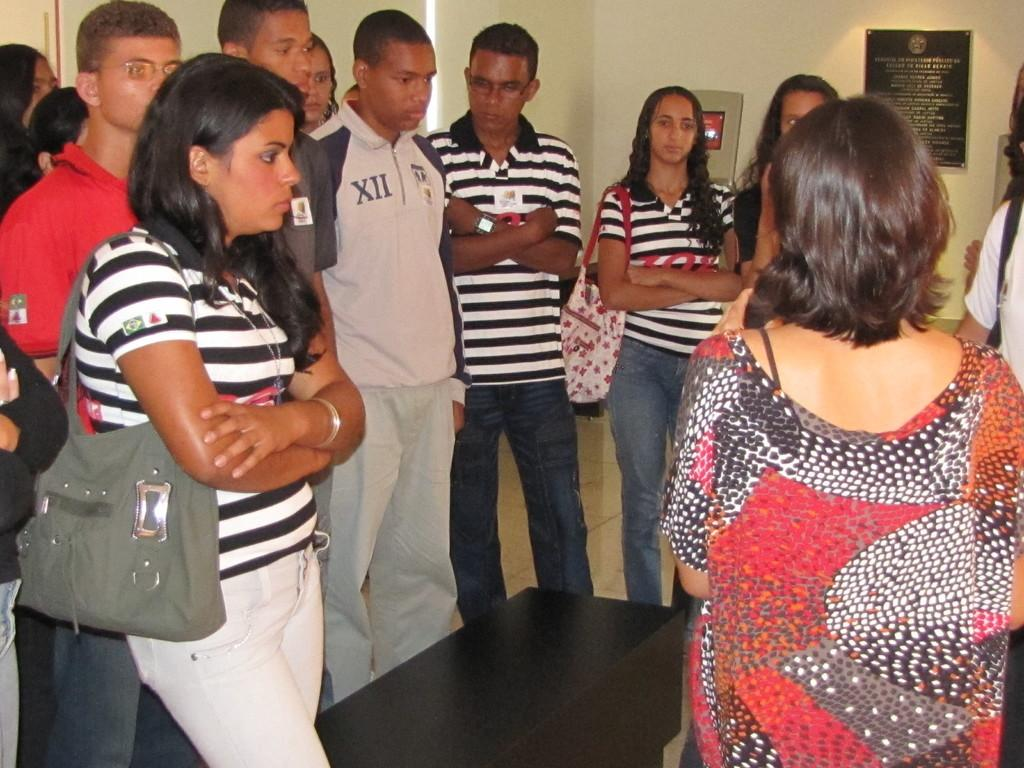How many people are present in the image? There are many people in the image. Where are the people located? The people are standing in a room. What can be seen on the wall in the image? There is a board with text on the wall in the image. What type of story is being told on the shelf in the image? There is no shelf present in the image, and therefore no story can be observed. 